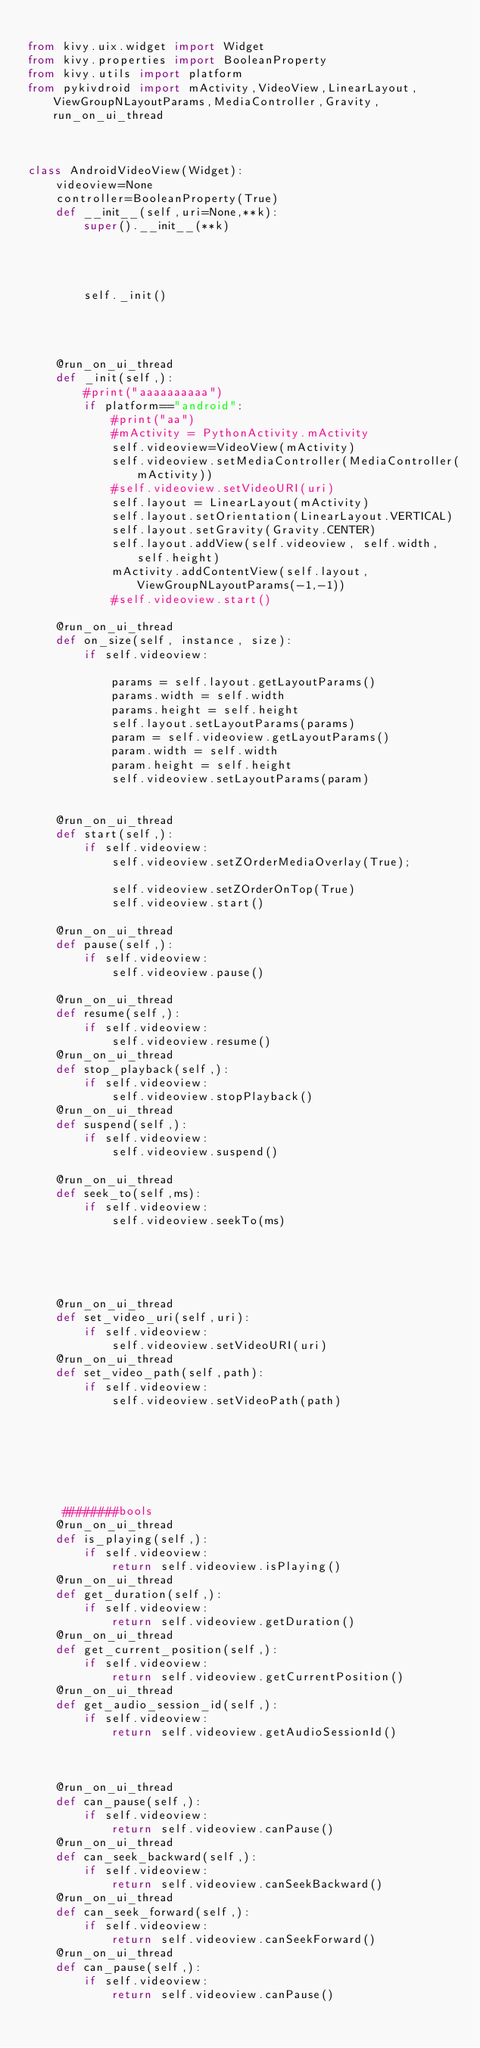Convert code to text. <code><loc_0><loc_0><loc_500><loc_500><_Python_>
from kivy.uix.widget import Widget
from kivy.properties import BooleanProperty
from kivy.utils import platform
from pykivdroid import mActivity,VideoView,LinearLayout,ViewGroupNLayoutParams,MediaController,Gravity,run_on_ui_thread



class AndroidVideoView(Widget):
    videoview=None
    controller=BooleanProperty(True)
    def __init__(self,uri=None,**k):
        super().__init__(**k)


        

        self._init()
        
        
       
    
    @run_on_ui_thread        
    def _init(self,):
        #print("aaaaaaaaaa")
        if platform=="android":
            #print("aa")
            #mActivity = PythonActivity.mActivity 
            self.videoview=VideoView(mActivity)
            self.videoview.setMediaController(MediaController(mActivity))
            #self.videoview.setVideoURI(uri)
            self.layout = LinearLayout(mActivity)
            self.layout.setOrientation(LinearLayout.VERTICAL)
            self.layout.setGravity(Gravity.CENTER)
            self.layout.addView(self.videoview, self.width, self.height)
            mActivity.addContentView(self.layout, ViewGroupNLayoutParams(-1,-1))
            #self.videoview.start()

    @run_on_ui_thread
    def on_size(self, instance, size):
        if self.videoview:
        
            params = self.layout.getLayoutParams()
            params.width = self.width
            params.height = self.height
            self.layout.setLayoutParams(params)
            param = self.videoview.getLayoutParams()
            param.width = self.width
            param.height = self.height
            self.videoview.setLayoutParams(param)


    @run_on_ui_thread
    def start(self,):
        if self.videoview:
            self.videoview.setZOrderMediaOverlay(True);

            self.videoview.setZOrderOnTop(True)
            self.videoview.start()

    @run_on_ui_thread
    def pause(self,):
        if self.videoview:
            self.videoview.pause()

    @run_on_ui_thread
    def resume(self,):
        if self.videoview:
            self.videoview.resume()
    @run_on_ui_thread
    def stop_playback(self,):
        if self.videoview:
            self.videoview.stopPlayback()
    @run_on_ui_thread
    def suspend(self,):
        if self.videoview:
            self.videoview.suspend()
    
    @run_on_ui_thread
    def seek_to(self,ms):
        if self.videoview:
            self.videoview.seekTo(ms)





    @run_on_ui_thread
    def set_video_uri(self,uri):
        if self.videoview:
            self.videoview.setVideoURI(uri)
    @run_on_ui_thread
    def set_video_path(self,path):
        if self.videoview:
            self.videoview.setVideoPath(path)
    






     ########bools        
    @run_on_ui_thread
    def is_playing(self,):
        if self.videoview:
            return self.videoview.isPlaying()
    @run_on_ui_thread
    def get_duration(self,):
        if self.videoview:
            return self.videoview.getDuration()
    @run_on_ui_thread
    def get_current_position(self,):
        if self.videoview:
            return self.videoview.getCurrentPosition()
    @run_on_ui_thread
    def get_audio_session_id(self,):
        if self.videoview:
            return self.videoview.getAudioSessionId()



    @run_on_ui_thread
    def can_pause(self,):
        if self.videoview:
            return self.videoview.canPause()
    @run_on_ui_thread
    def can_seek_backward(self,):
        if self.videoview:
            return self.videoview.canSeekBackward()
    @run_on_ui_thread
    def can_seek_forward(self,):
        if self.videoview:
            return self.videoview.canSeekForward()
    @run_on_ui_thread
    def can_pause(self,):
        if self.videoview:
            return self.videoview.canPause()










 
</code> 